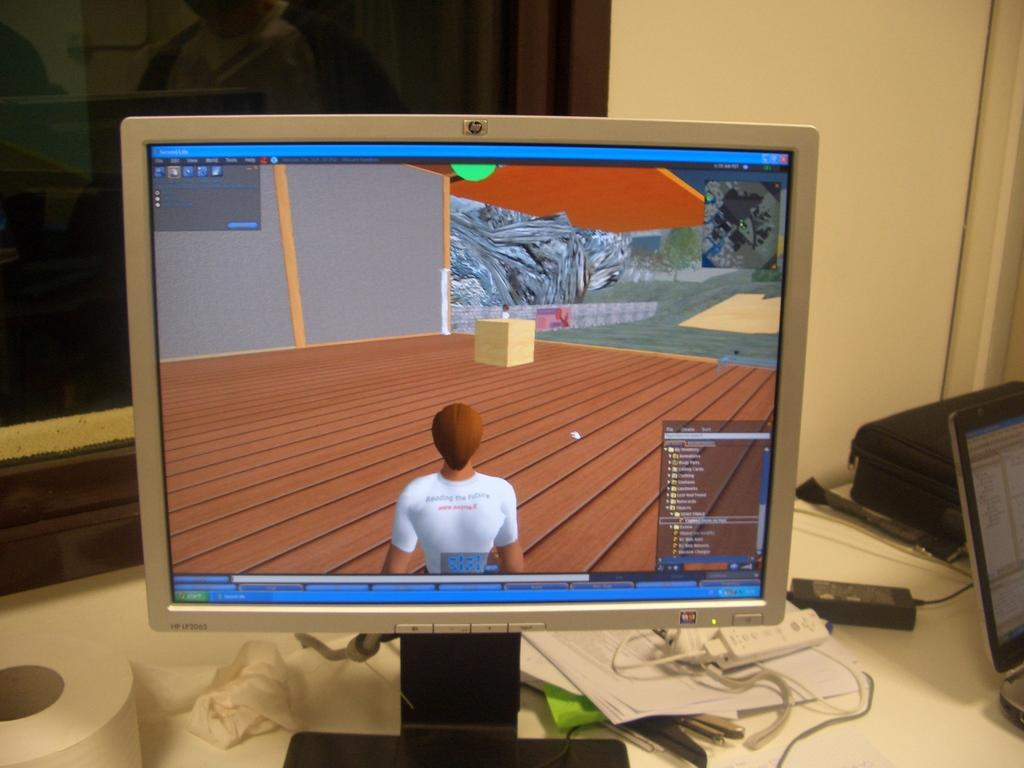<image>
Summarize the visual content of the image. An HP LP2065 monitor has a person on the screen in a white shirt. 